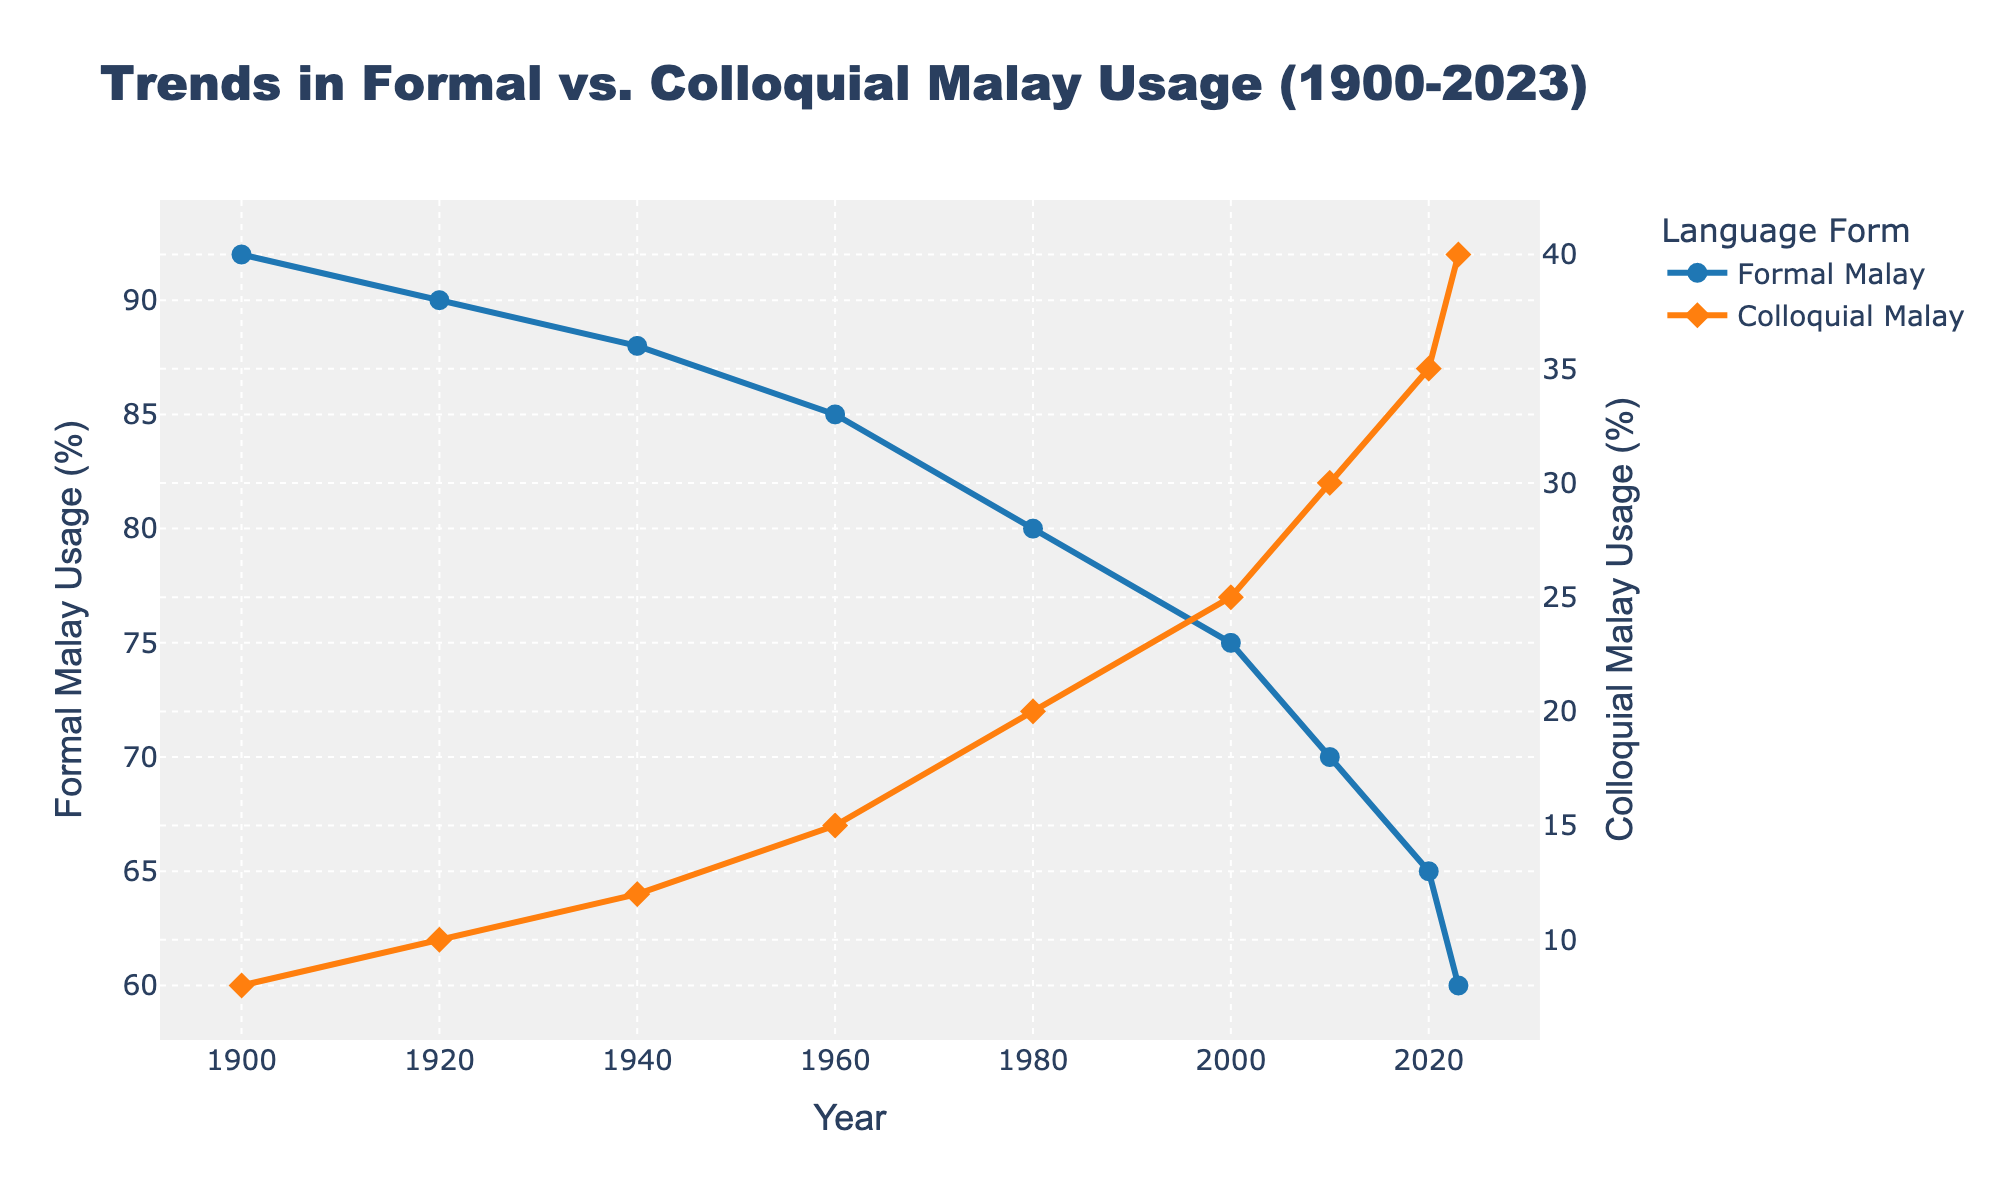what year did the usage of formal Malay drop below 85%? By examining the figure, it is evident that the formal Malay usage percentage fell below 85% in the year where the line crosses the 85% threshold. This occurred in 1960.
Answer: 1960 which form of Malay had a higher usage in 2023, formal or colloquial Malay? By analyzing the endpoints of both lines, we see that in 2023, the formal Malay usage was at 60% while the colloquial Malay usage was at 40%. Formal Malay had the higher usage.
Answer: Formal Malay between which years did colloquial Malay see the highest increase in usage? Observing the slope of the colloquial Malay line, the steepest rise is between 2010 and 2023, indicating the highest increase in usage.
Answer: 2010 to 2023 how much did formal Malay usage decrease from 1900 to 2023? By subtracting the formal Malay usage in 2023 (60%) from the usage in 1900 (92%), we get a decrease of 32%.
Answer: 32% in what year did colloquial Malay usage reach 25%? Reviewing the figure, colloquial Malay reached 25% usage around the year 2000.
Answer: 2000 at what point in time did formal and colloquial Malay have roughly equal rates of decrease and increase, respectively? The trend lines suggest that around 2023, formal Malay's usage decrease rate and colloquial Malay's usage increase rate appear to be close in the amount of change per year.
Answer: Around 2023 by how much did colloquial Malay usage increase between 2000 and 2020? Subtract the colloquial Malay usage in 2000 (25%) from the usage in 2020 (35%) to find an increase of 10%.
Answer: 10% what was the difference in the usage percentage between formal and colloquial Malay in 1980? The figure shows formal Malay at 80% and colloquial Malay at 20% in 1980. The difference is 80% - 20% = 60%.
Answer: 60% what is the average usage of formal Malay across all the years presented? To find the average usage of formal Malay, add all the percentages from each year (92+90+88+85+80+75+70+65+60) and divide by the number of years (9). This equals (695/9) ≈ 77.22%.
Answer: 77.22% which form of Malay changed usage more steeply between 1980 and 2023, and by how much? By comparing both trends from 1980 (80% formal and 20% colloquial) to 2023 (60% formal and 40% colloquial), formal Malay dropped by 20% while colloquial rose by 20%. The comparative steepness in change is 0% difference in change amount.
Answer: Both were equally steep by 20% 